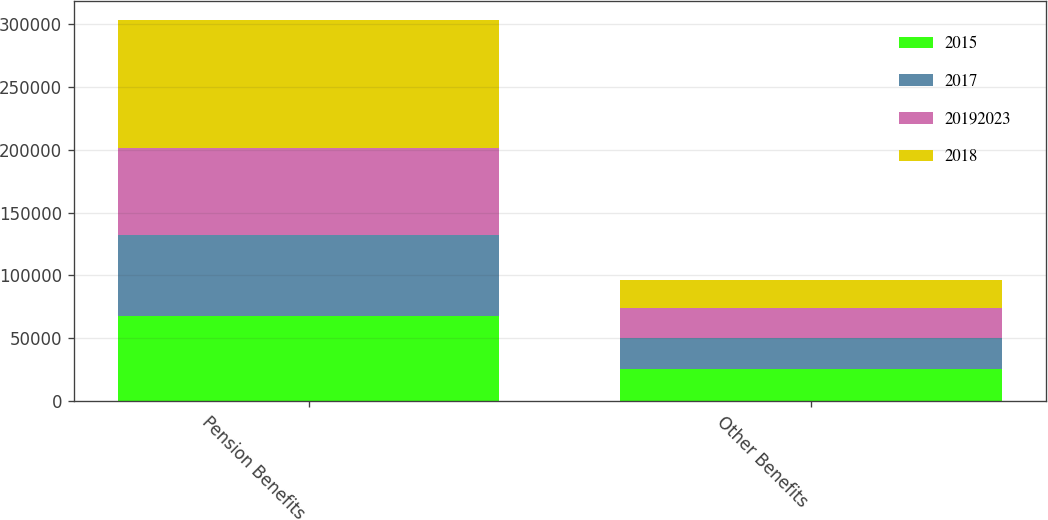Convert chart to OTSL. <chart><loc_0><loc_0><loc_500><loc_500><stacked_bar_chart><ecel><fcel>Pension Benefits<fcel>Other Benefits<nl><fcel>2015<fcel>67617<fcel>25491<nl><fcel>2017<fcel>64641<fcel>24690<nl><fcel>2.0192e+07<fcel>69085<fcel>23796<nl><fcel>2018<fcel>101765<fcel>22411<nl></chart> 